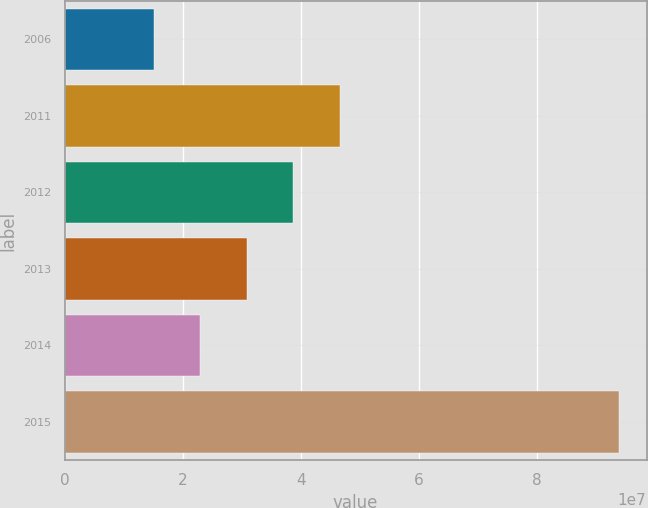Convert chart to OTSL. <chart><loc_0><loc_0><loc_500><loc_500><bar_chart><fcel>2006<fcel>2011<fcel>2012<fcel>2013<fcel>2014<fcel>2015<nl><fcel>1.512e+07<fcel>4.66244e+07<fcel>3.87483e+07<fcel>3.08722e+07<fcel>2.29961e+07<fcel>9.3881e+07<nl></chart> 